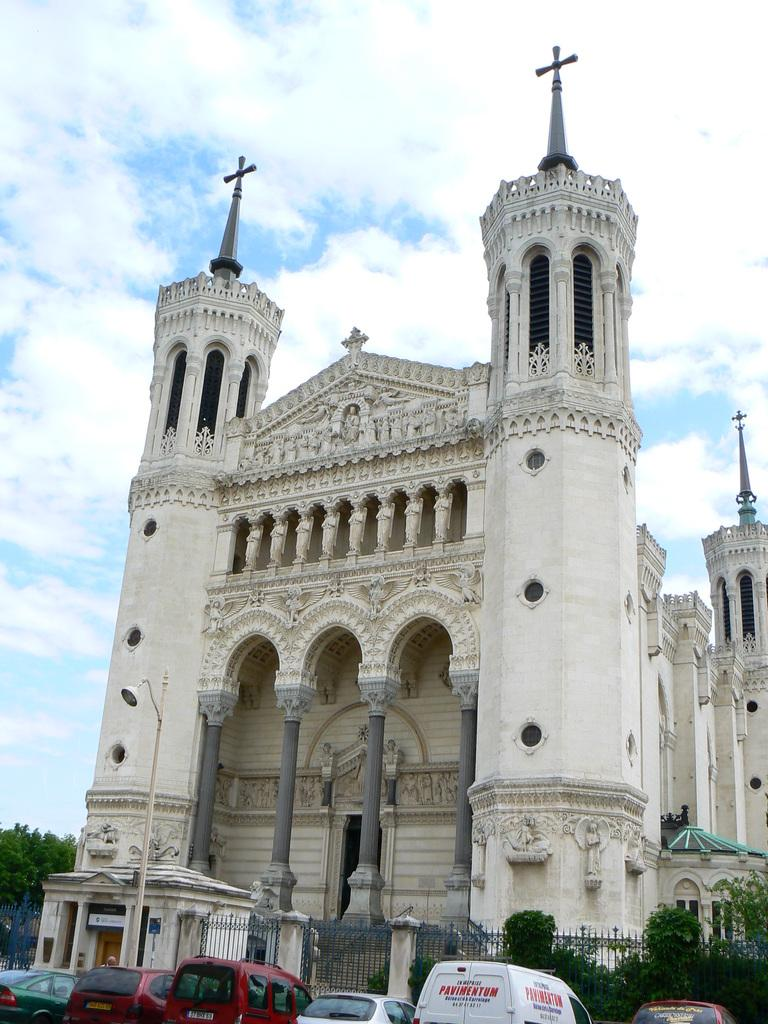What can be seen parked in the image? There are cars parked in the image. What type of barrier is present in the image? There is a fence in the image. What type of vegetation is visible in the image? There are trees in the image. What type of entrance is present in the image? There is a gate in the image. What type of building is visible in the image? There is a stone building in the image. What is visible in the background of the image? The sky is visible in the background of the image. What can be seen in the sky in the image? There are clouds in the sky. Where is the hose located in the image? There is no hose present in the image. What type of calendar is hanging on the stone building in the image? There is no calendar present in the image. 